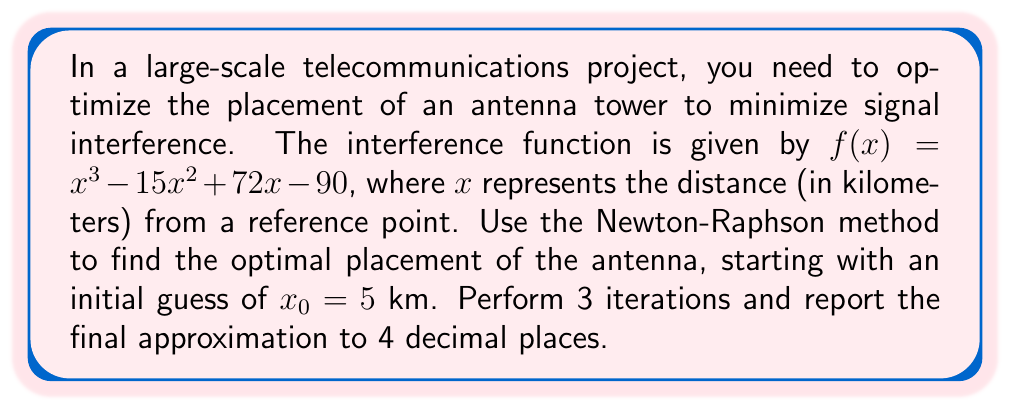Provide a solution to this math problem. The Newton-Raphson method is given by the formula:

$$x_{n+1} = x_n - \frac{f(x_n)}{f'(x_n)}$$

Where $f'(x)$ is the derivative of $f(x)$.

Step 1: Calculate $f'(x)$
$f'(x) = 3x^2 - 30x + 72$

Step 2: Set up the iteration formula
$$x_{n+1} = x_n - \frac{x_n^3 - 15x_n^2 + 72x_n - 90}{3x_n^2 - 30x_n + 72}$$

Step 3: Perform 3 iterations

Iteration 1:
$x_1 = 5 - \frac{5^3 - 15(5^2) + 72(5) - 90}{3(5^2) - 30(5) + 72}$
$x_1 = 5 - \frac{125 - 375 + 360 - 90}{75 - 150 + 72}$
$x_1 = 5 - \frac{20}{-3} = 5 + \frac{20}{3} = 11.6667$

Iteration 2:
$x_2 = 11.6667 - \frac{11.6667^3 - 15(11.6667^2) + 72(11.6667) - 90}{3(11.6667^2) - 30(11.6667) + 72}$
$x_2 = 11.6667 - \frac{1588.8889 - 2041.6675 + 840.0024 - 90}{408.3345 - 350.001 + 72}$
$x_2 = 11.6667 - \frac{297.2238}{130.3335} = 9.3827$

Iteration 3:
$x_3 = 9.3827 - \frac{9.3827^3 - 15(9.3827^2) + 72(9.3827) - 90}{3(9.3827^2) - 30(9.3827) + 72}$
$x_3 = 9.3827 - \frac{825.6246 - 1319.6985 + 675.5544 - 90}{263.9469 - 281.481 + 72}$
$x_3 = 9.3827 - \frac{91.4805}{54.4659} = 7.7025$
Answer: 7.7025 km 